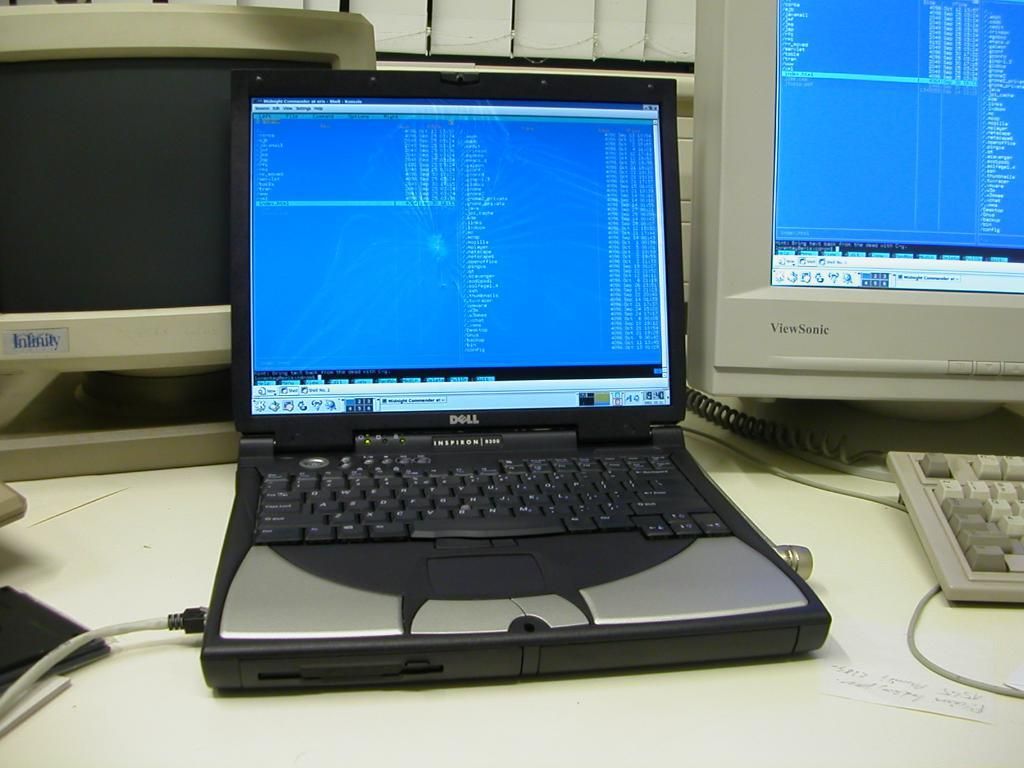Provide a one-sentence caption for the provided image. The lap top sitting on the desk with other workstations was made by Dell. 